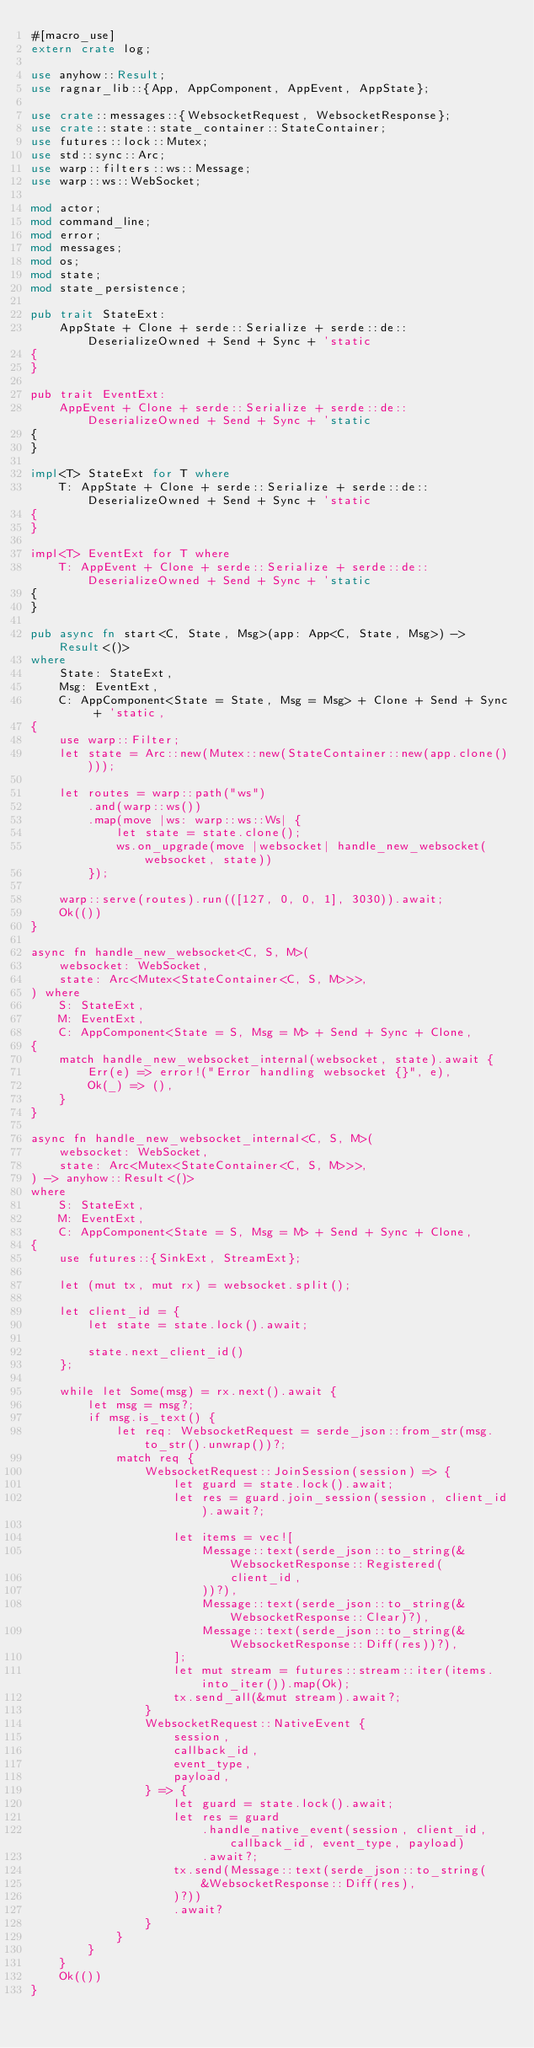<code> <loc_0><loc_0><loc_500><loc_500><_Rust_>#[macro_use]
extern crate log;

use anyhow::Result;
use ragnar_lib::{App, AppComponent, AppEvent, AppState};

use crate::messages::{WebsocketRequest, WebsocketResponse};
use crate::state::state_container::StateContainer;
use futures::lock::Mutex;
use std::sync::Arc;
use warp::filters::ws::Message;
use warp::ws::WebSocket;

mod actor;
mod command_line;
mod error;
mod messages;
mod os;
mod state;
mod state_persistence;

pub trait StateExt:
    AppState + Clone + serde::Serialize + serde::de::DeserializeOwned + Send + Sync + 'static
{
}

pub trait EventExt:
    AppEvent + Clone + serde::Serialize + serde::de::DeserializeOwned + Send + Sync + 'static
{
}

impl<T> StateExt for T where
    T: AppState + Clone + serde::Serialize + serde::de::DeserializeOwned + Send + Sync + 'static
{
}

impl<T> EventExt for T where
    T: AppEvent + Clone + serde::Serialize + serde::de::DeserializeOwned + Send + Sync + 'static
{
}

pub async fn start<C, State, Msg>(app: App<C, State, Msg>) -> Result<()>
where
    State: StateExt,
    Msg: EventExt,
    C: AppComponent<State = State, Msg = Msg> + Clone + Send + Sync + 'static,
{
    use warp::Filter;
    let state = Arc::new(Mutex::new(StateContainer::new(app.clone())));

    let routes = warp::path("ws")
        .and(warp::ws())
        .map(move |ws: warp::ws::Ws| {
            let state = state.clone();
            ws.on_upgrade(move |websocket| handle_new_websocket(websocket, state))
        });

    warp::serve(routes).run(([127, 0, 0, 1], 3030)).await;
    Ok(())
}

async fn handle_new_websocket<C, S, M>(
    websocket: WebSocket,
    state: Arc<Mutex<StateContainer<C, S, M>>>,
) where
    S: StateExt,
    M: EventExt,
    C: AppComponent<State = S, Msg = M> + Send + Sync + Clone,
{
    match handle_new_websocket_internal(websocket, state).await {
        Err(e) => error!("Error handling websocket {}", e),
        Ok(_) => (),
    }
}

async fn handle_new_websocket_internal<C, S, M>(
    websocket: WebSocket,
    state: Arc<Mutex<StateContainer<C, S, M>>>,
) -> anyhow::Result<()>
where
    S: StateExt,
    M: EventExt,
    C: AppComponent<State = S, Msg = M> + Send + Sync + Clone,
{
    use futures::{SinkExt, StreamExt};

    let (mut tx, mut rx) = websocket.split();

    let client_id = {
        let state = state.lock().await;

        state.next_client_id()
    };

    while let Some(msg) = rx.next().await {
        let msg = msg?;
        if msg.is_text() {
            let req: WebsocketRequest = serde_json::from_str(msg.to_str().unwrap())?;
            match req {
                WebsocketRequest::JoinSession(session) => {
                    let guard = state.lock().await;
                    let res = guard.join_session(session, client_id).await?;

                    let items = vec![
                        Message::text(serde_json::to_string(&WebsocketResponse::Registered(
                            client_id,
                        ))?),
                        Message::text(serde_json::to_string(&WebsocketResponse::Clear)?),
                        Message::text(serde_json::to_string(&WebsocketResponse::Diff(res))?),
                    ];
                    let mut stream = futures::stream::iter(items.into_iter()).map(Ok);
                    tx.send_all(&mut stream).await?;
                }
                WebsocketRequest::NativeEvent {
                    session,
                    callback_id,
                    event_type,
                    payload,
                } => {
                    let guard = state.lock().await;
                    let res = guard
                        .handle_native_event(session, client_id, callback_id, event_type, payload)
                        .await?;
                    tx.send(Message::text(serde_json::to_string(
                        &WebsocketResponse::Diff(res),
                    )?))
                    .await?
                }
            }
        }
    }
    Ok(())
}
</code> 